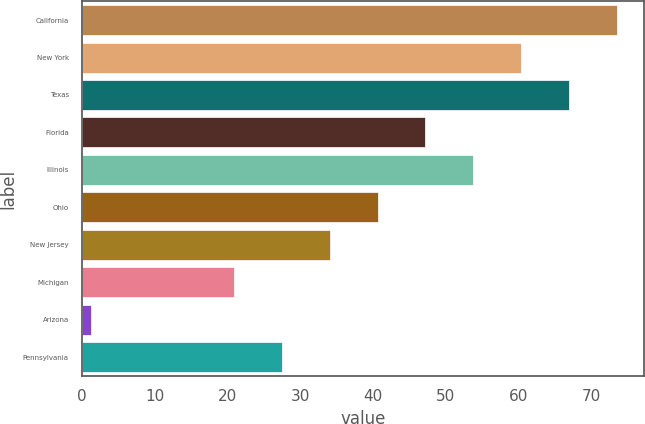Convert chart. <chart><loc_0><loc_0><loc_500><loc_500><bar_chart><fcel>California<fcel>New York<fcel>Texas<fcel>Florida<fcel>Illinois<fcel>Ohio<fcel>New Jersey<fcel>Michigan<fcel>Arizona<fcel>Pennsylvania<nl><fcel>73.47<fcel>60.33<fcel>66.9<fcel>47.19<fcel>53.76<fcel>40.62<fcel>34.05<fcel>20.91<fcel>1.2<fcel>27.48<nl></chart> 